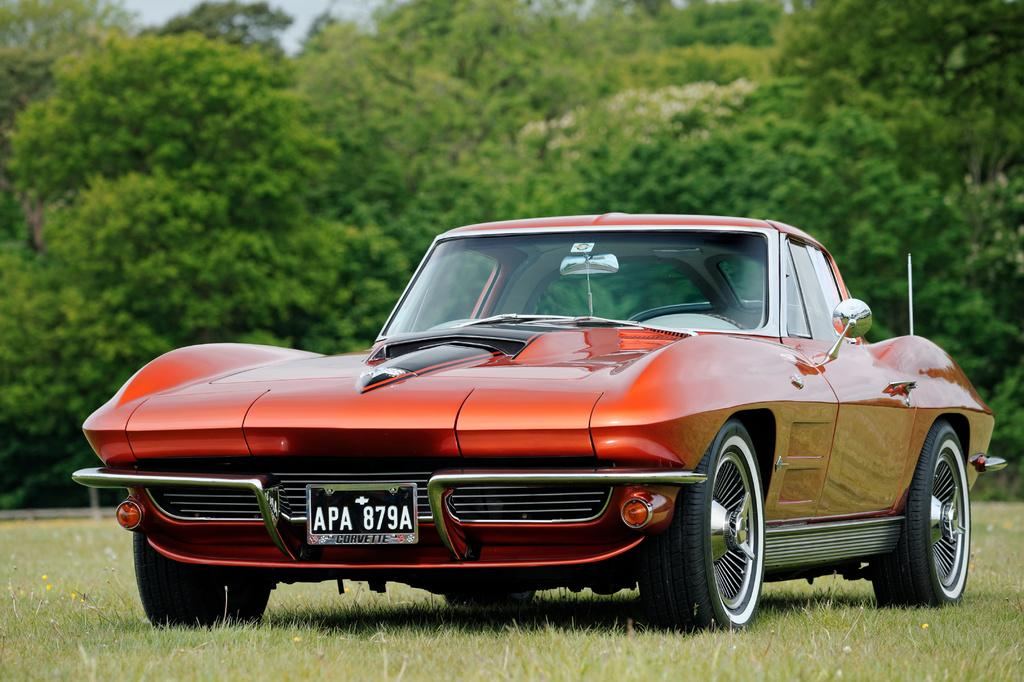What is the main subject of the image? The main subject of the image is a car. What type of natural environment is visible in the image? There is grass and trees visible in the image. What is visible at the top of the image? The sky is visible at the top of the image. Can you tell me how many snails are crawling on the car in the image? There are no snails visible on the car in the image. What type of hen can be seen in the image? There is no hen present in the image. 